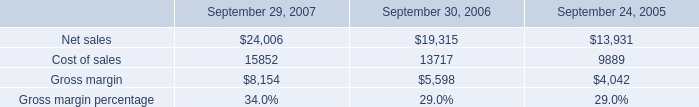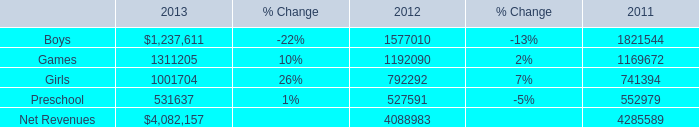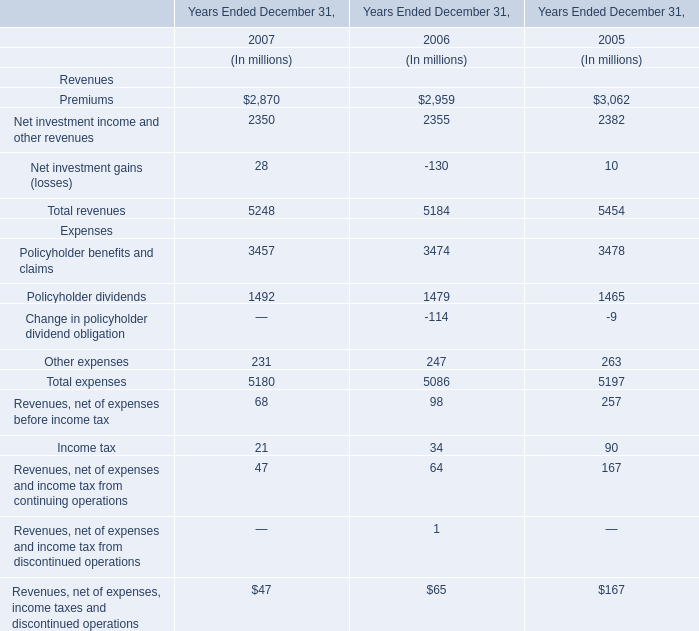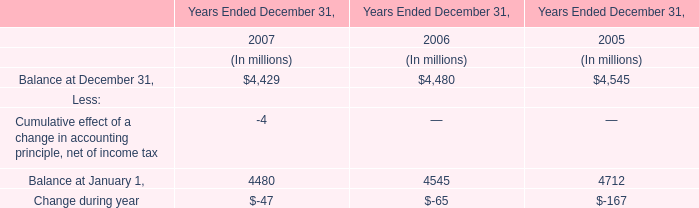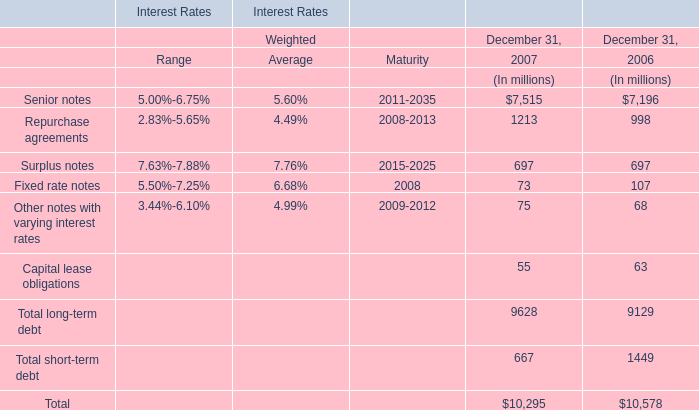what was the percentage sales change from 2005 to 2006? 
Computations: ((19315 - 13931) / 13931)
Answer: 0.38648. 